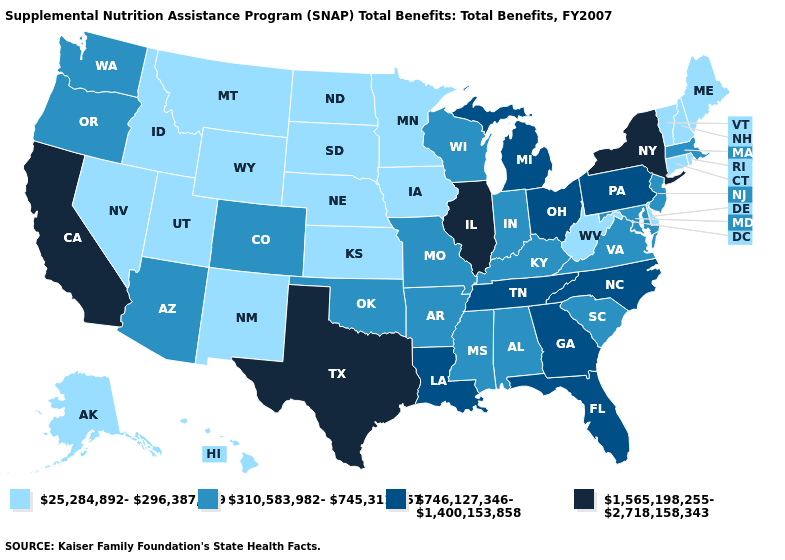Among the states that border New Mexico , does Utah have the highest value?
Quick response, please. No. Does Oregon have the lowest value in the USA?
Write a very short answer. No. Which states hav the highest value in the Northeast?
Concise answer only. New York. What is the value of South Carolina?
Answer briefly. 310,583,982-745,311,957. What is the value of Virginia?
Give a very brief answer. 310,583,982-745,311,957. What is the value of Arizona?
Quick response, please. 310,583,982-745,311,957. What is the value of Colorado?
Answer briefly. 310,583,982-745,311,957. How many symbols are there in the legend?
Be succinct. 4. Name the states that have a value in the range 25,284,892-296,387,269?
Keep it brief. Alaska, Connecticut, Delaware, Hawaii, Idaho, Iowa, Kansas, Maine, Minnesota, Montana, Nebraska, Nevada, New Hampshire, New Mexico, North Dakota, Rhode Island, South Dakota, Utah, Vermont, West Virginia, Wyoming. What is the lowest value in the South?
Quick response, please. 25,284,892-296,387,269. Name the states that have a value in the range 25,284,892-296,387,269?
Write a very short answer. Alaska, Connecticut, Delaware, Hawaii, Idaho, Iowa, Kansas, Maine, Minnesota, Montana, Nebraska, Nevada, New Hampshire, New Mexico, North Dakota, Rhode Island, South Dakota, Utah, Vermont, West Virginia, Wyoming. What is the value of North Carolina?
Write a very short answer. 746,127,346-1,400,153,858. Does South Dakota have a lower value than New Mexico?
Keep it brief. No. Which states have the highest value in the USA?
Keep it brief. California, Illinois, New York, Texas. Among the states that border Missouri , does Oklahoma have the highest value?
Give a very brief answer. No. 